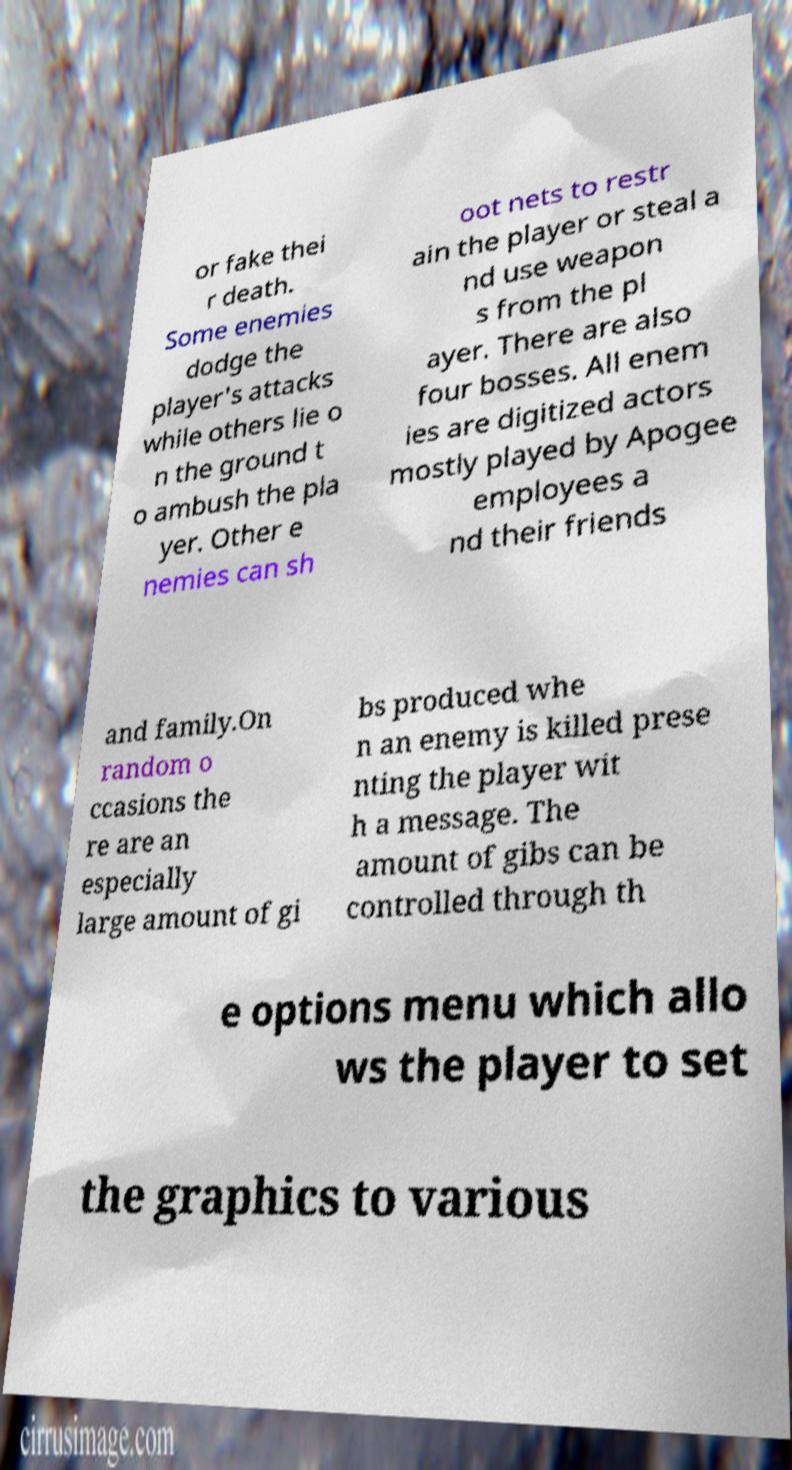There's text embedded in this image that I need extracted. Can you transcribe it verbatim? or fake thei r death. Some enemies dodge the player's attacks while others lie o n the ground t o ambush the pla yer. Other e nemies can sh oot nets to restr ain the player or steal a nd use weapon s from the pl ayer. There are also four bosses. All enem ies are digitized actors mostly played by Apogee employees a nd their friends and family.On random o ccasions the re are an especially large amount of gi bs produced whe n an enemy is killed prese nting the player wit h a message. The amount of gibs can be controlled through th e options menu which allo ws the player to set the graphics to various 